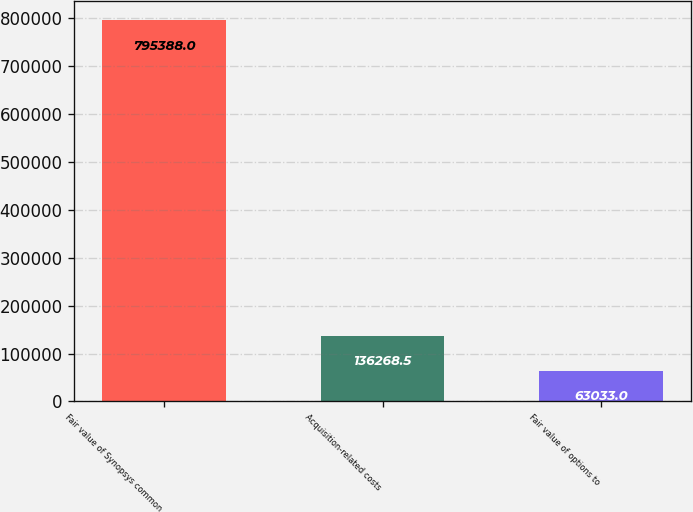<chart> <loc_0><loc_0><loc_500><loc_500><bar_chart><fcel>Fair value of Synopsys common<fcel>Acquisition-related costs<fcel>Fair value of options to<nl><fcel>795388<fcel>136268<fcel>63033<nl></chart> 